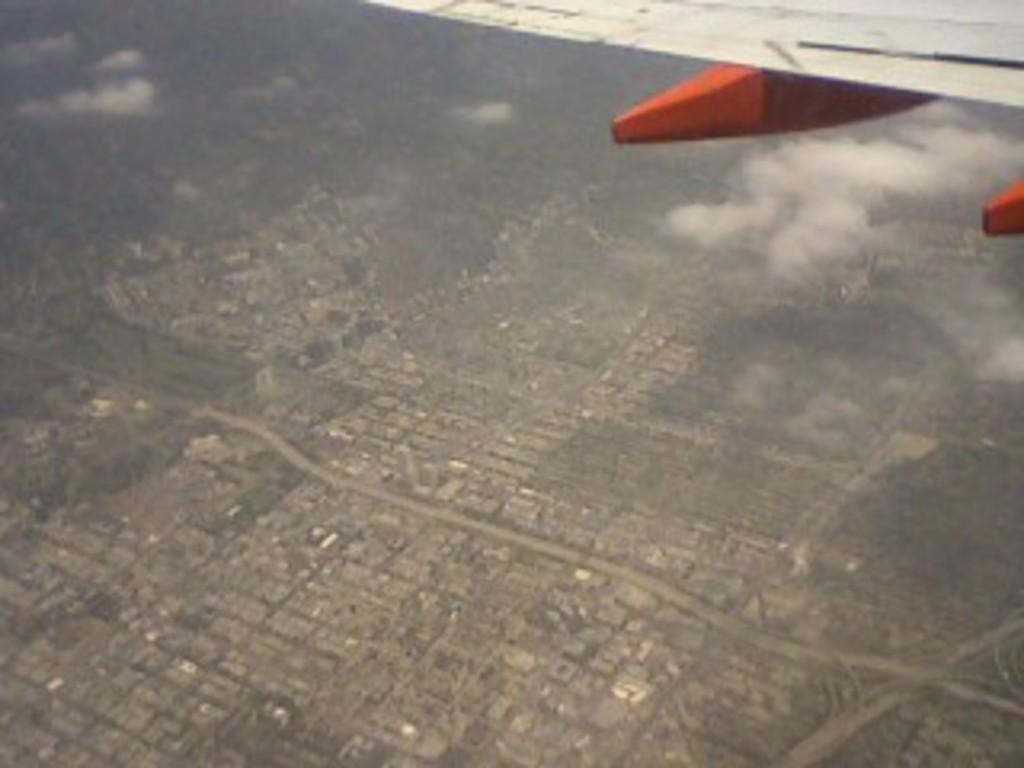Can you describe this image briefly? This picture shows a top view from a plane and we see buildings. 